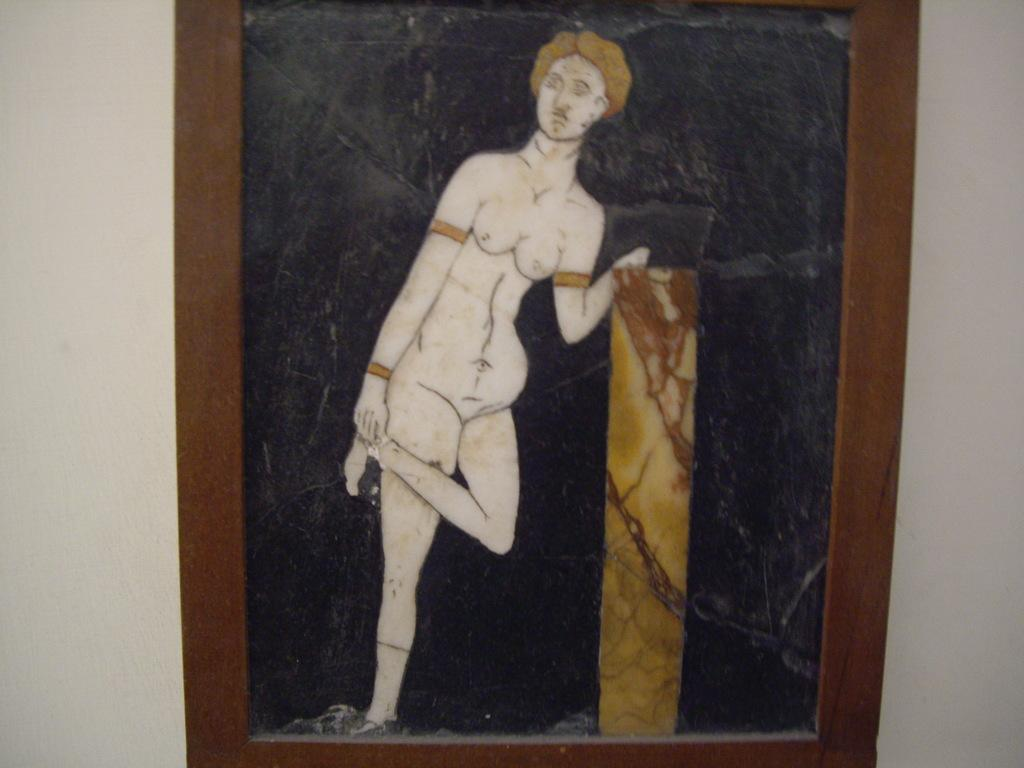What is hanging on the wall in the image? There is a frame on the wall in the image. What is inside the frame? The frame appears to contain a picture of a human. What type of branch is growing out of the person's head in the image? There is no branch growing out of the person's head in the image; it is a picture of a human inside a frame. 